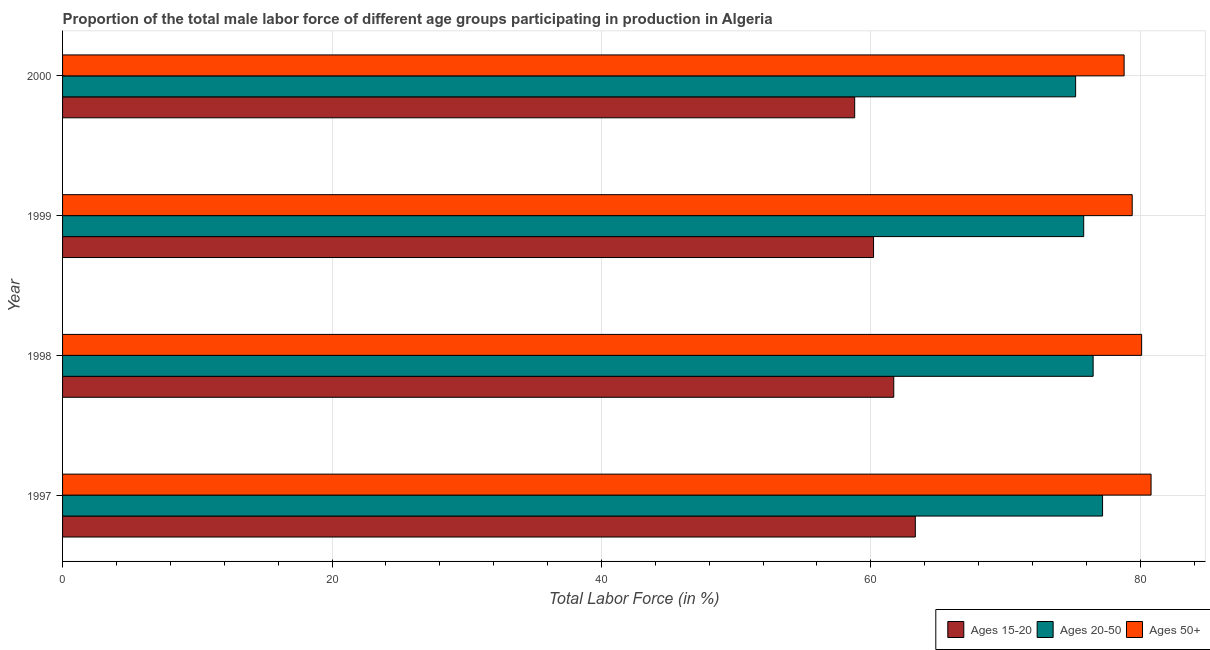How many different coloured bars are there?
Keep it short and to the point. 3. How many groups of bars are there?
Your answer should be compact. 4. Are the number of bars on each tick of the Y-axis equal?
Offer a terse response. Yes. How many bars are there on the 1st tick from the top?
Offer a very short reply. 3. What is the percentage of male labor force above age 50 in 1999?
Provide a succinct answer. 79.4. Across all years, what is the maximum percentage of male labor force within the age group 20-50?
Your answer should be compact. 77.2. Across all years, what is the minimum percentage of male labor force above age 50?
Your answer should be compact. 78.8. In which year was the percentage of male labor force above age 50 maximum?
Ensure brevity in your answer.  1997. What is the total percentage of male labor force above age 50 in the graph?
Make the answer very short. 319.1. What is the difference between the percentage of male labor force above age 50 in 1997 and the percentage of male labor force within the age group 15-20 in 1998?
Your response must be concise. 19.1. What is the average percentage of male labor force above age 50 per year?
Your answer should be compact. 79.78. In the year 2000, what is the difference between the percentage of male labor force within the age group 20-50 and percentage of male labor force within the age group 15-20?
Ensure brevity in your answer.  16.4. What is the ratio of the percentage of male labor force within the age group 15-20 in 1997 to that in 1999?
Offer a terse response. 1.05. What does the 2nd bar from the top in 1999 represents?
Your answer should be compact. Ages 20-50. What does the 2nd bar from the bottom in 1997 represents?
Offer a very short reply. Ages 20-50. Is it the case that in every year, the sum of the percentage of male labor force within the age group 15-20 and percentage of male labor force within the age group 20-50 is greater than the percentage of male labor force above age 50?
Ensure brevity in your answer.  Yes. What is the difference between two consecutive major ticks on the X-axis?
Offer a terse response. 20. Does the graph contain any zero values?
Offer a terse response. No. Does the graph contain grids?
Ensure brevity in your answer.  Yes. Where does the legend appear in the graph?
Make the answer very short. Bottom right. How many legend labels are there?
Your response must be concise. 3. How are the legend labels stacked?
Your answer should be very brief. Horizontal. What is the title of the graph?
Make the answer very short. Proportion of the total male labor force of different age groups participating in production in Algeria. What is the label or title of the Y-axis?
Your answer should be compact. Year. What is the Total Labor Force (in %) in Ages 15-20 in 1997?
Give a very brief answer. 63.3. What is the Total Labor Force (in %) in Ages 20-50 in 1997?
Your answer should be very brief. 77.2. What is the Total Labor Force (in %) of Ages 50+ in 1997?
Provide a succinct answer. 80.8. What is the Total Labor Force (in %) in Ages 15-20 in 1998?
Provide a short and direct response. 61.7. What is the Total Labor Force (in %) of Ages 20-50 in 1998?
Give a very brief answer. 76.5. What is the Total Labor Force (in %) in Ages 50+ in 1998?
Offer a very short reply. 80.1. What is the Total Labor Force (in %) in Ages 15-20 in 1999?
Keep it short and to the point. 60.2. What is the Total Labor Force (in %) in Ages 20-50 in 1999?
Your answer should be very brief. 75.8. What is the Total Labor Force (in %) of Ages 50+ in 1999?
Provide a short and direct response. 79.4. What is the Total Labor Force (in %) in Ages 15-20 in 2000?
Your answer should be very brief. 58.8. What is the Total Labor Force (in %) of Ages 20-50 in 2000?
Offer a terse response. 75.2. What is the Total Labor Force (in %) of Ages 50+ in 2000?
Your answer should be compact. 78.8. Across all years, what is the maximum Total Labor Force (in %) in Ages 15-20?
Offer a terse response. 63.3. Across all years, what is the maximum Total Labor Force (in %) of Ages 20-50?
Ensure brevity in your answer.  77.2. Across all years, what is the maximum Total Labor Force (in %) of Ages 50+?
Give a very brief answer. 80.8. Across all years, what is the minimum Total Labor Force (in %) of Ages 15-20?
Ensure brevity in your answer.  58.8. Across all years, what is the minimum Total Labor Force (in %) in Ages 20-50?
Your response must be concise. 75.2. Across all years, what is the minimum Total Labor Force (in %) in Ages 50+?
Your response must be concise. 78.8. What is the total Total Labor Force (in %) of Ages 15-20 in the graph?
Your response must be concise. 244. What is the total Total Labor Force (in %) of Ages 20-50 in the graph?
Make the answer very short. 304.7. What is the total Total Labor Force (in %) in Ages 50+ in the graph?
Your response must be concise. 319.1. What is the difference between the Total Labor Force (in %) in Ages 15-20 in 1997 and that in 1998?
Make the answer very short. 1.6. What is the difference between the Total Labor Force (in %) in Ages 50+ in 1997 and that in 1998?
Give a very brief answer. 0.7. What is the difference between the Total Labor Force (in %) of Ages 15-20 in 1997 and that in 1999?
Your answer should be compact. 3.1. What is the difference between the Total Labor Force (in %) in Ages 15-20 in 1997 and that in 2000?
Give a very brief answer. 4.5. What is the difference between the Total Labor Force (in %) in Ages 20-50 in 1998 and that in 1999?
Keep it short and to the point. 0.7. What is the difference between the Total Labor Force (in %) in Ages 50+ in 1998 and that in 1999?
Your answer should be very brief. 0.7. What is the difference between the Total Labor Force (in %) of Ages 20-50 in 1998 and that in 2000?
Offer a terse response. 1.3. What is the difference between the Total Labor Force (in %) of Ages 50+ in 1998 and that in 2000?
Ensure brevity in your answer.  1.3. What is the difference between the Total Labor Force (in %) in Ages 20-50 in 1999 and that in 2000?
Keep it short and to the point. 0.6. What is the difference between the Total Labor Force (in %) of Ages 15-20 in 1997 and the Total Labor Force (in %) of Ages 20-50 in 1998?
Provide a short and direct response. -13.2. What is the difference between the Total Labor Force (in %) in Ages 15-20 in 1997 and the Total Labor Force (in %) in Ages 50+ in 1998?
Provide a short and direct response. -16.8. What is the difference between the Total Labor Force (in %) of Ages 20-50 in 1997 and the Total Labor Force (in %) of Ages 50+ in 1998?
Give a very brief answer. -2.9. What is the difference between the Total Labor Force (in %) in Ages 15-20 in 1997 and the Total Labor Force (in %) in Ages 20-50 in 1999?
Make the answer very short. -12.5. What is the difference between the Total Labor Force (in %) of Ages 15-20 in 1997 and the Total Labor Force (in %) of Ages 50+ in 1999?
Offer a terse response. -16.1. What is the difference between the Total Labor Force (in %) of Ages 20-50 in 1997 and the Total Labor Force (in %) of Ages 50+ in 1999?
Provide a short and direct response. -2.2. What is the difference between the Total Labor Force (in %) in Ages 15-20 in 1997 and the Total Labor Force (in %) in Ages 50+ in 2000?
Ensure brevity in your answer.  -15.5. What is the difference between the Total Labor Force (in %) of Ages 15-20 in 1998 and the Total Labor Force (in %) of Ages 20-50 in 1999?
Your response must be concise. -14.1. What is the difference between the Total Labor Force (in %) in Ages 15-20 in 1998 and the Total Labor Force (in %) in Ages 50+ in 1999?
Your answer should be very brief. -17.7. What is the difference between the Total Labor Force (in %) of Ages 20-50 in 1998 and the Total Labor Force (in %) of Ages 50+ in 1999?
Offer a very short reply. -2.9. What is the difference between the Total Labor Force (in %) of Ages 15-20 in 1998 and the Total Labor Force (in %) of Ages 20-50 in 2000?
Your response must be concise. -13.5. What is the difference between the Total Labor Force (in %) in Ages 15-20 in 1998 and the Total Labor Force (in %) in Ages 50+ in 2000?
Offer a very short reply. -17.1. What is the difference between the Total Labor Force (in %) in Ages 15-20 in 1999 and the Total Labor Force (in %) in Ages 50+ in 2000?
Offer a very short reply. -18.6. What is the difference between the Total Labor Force (in %) in Ages 20-50 in 1999 and the Total Labor Force (in %) in Ages 50+ in 2000?
Your response must be concise. -3. What is the average Total Labor Force (in %) in Ages 20-50 per year?
Give a very brief answer. 76.17. What is the average Total Labor Force (in %) in Ages 50+ per year?
Offer a very short reply. 79.78. In the year 1997, what is the difference between the Total Labor Force (in %) in Ages 15-20 and Total Labor Force (in %) in Ages 50+?
Provide a short and direct response. -17.5. In the year 1997, what is the difference between the Total Labor Force (in %) in Ages 20-50 and Total Labor Force (in %) in Ages 50+?
Your answer should be very brief. -3.6. In the year 1998, what is the difference between the Total Labor Force (in %) of Ages 15-20 and Total Labor Force (in %) of Ages 20-50?
Your response must be concise. -14.8. In the year 1998, what is the difference between the Total Labor Force (in %) of Ages 15-20 and Total Labor Force (in %) of Ages 50+?
Your answer should be compact. -18.4. In the year 1999, what is the difference between the Total Labor Force (in %) in Ages 15-20 and Total Labor Force (in %) in Ages 20-50?
Your answer should be very brief. -15.6. In the year 1999, what is the difference between the Total Labor Force (in %) of Ages 15-20 and Total Labor Force (in %) of Ages 50+?
Give a very brief answer. -19.2. In the year 2000, what is the difference between the Total Labor Force (in %) of Ages 15-20 and Total Labor Force (in %) of Ages 20-50?
Your answer should be very brief. -16.4. In the year 2000, what is the difference between the Total Labor Force (in %) in Ages 15-20 and Total Labor Force (in %) in Ages 50+?
Provide a short and direct response. -20. What is the ratio of the Total Labor Force (in %) of Ages 15-20 in 1997 to that in 1998?
Your response must be concise. 1.03. What is the ratio of the Total Labor Force (in %) in Ages 20-50 in 1997 to that in 1998?
Offer a terse response. 1.01. What is the ratio of the Total Labor Force (in %) of Ages 50+ in 1997 to that in 1998?
Provide a short and direct response. 1.01. What is the ratio of the Total Labor Force (in %) of Ages 15-20 in 1997 to that in 1999?
Provide a short and direct response. 1.05. What is the ratio of the Total Labor Force (in %) of Ages 20-50 in 1997 to that in 1999?
Offer a terse response. 1.02. What is the ratio of the Total Labor Force (in %) in Ages 50+ in 1997 to that in 1999?
Ensure brevity in your answer.  1.02. What is the ratio of the Total Labor Force (in %) in Ages 15-20 in 1997 to that in 2000?
Offer a very short reply. 1.08. What is the ratio of the Total Labor Force (in %) of Ages 20-50 in 1997 to that in 2000?
Offer a terse response. 1.03. What is the ratio of the Total Labor Force (in %) in Ages 50+ in 1997 to that in 2000?
Offer a very short reply. 1.03. What is the ratio of the Total Labor Force (in %) in Ages 15-20 in 1998 to that in 1999?
Offer a terse response. 1.02. What is the ratio of the Total Labor Force (in %) in Ages 20-50 in 1998 to that in 1999?
Provide a short and direct response. 1.01. What is the ratio of the Total Labor Force (in %) of Ages 50+ in 1998 to that in 1999?
Keep it short and to the point. 1.01. What is the ratio of the Total Labor Force (in %) of Ages 15-20 in 1998 to that in 2000?
Your answer should be compact. 1.05. What is the ratio of the Total Labor Force (in %) in Ages 20-50 in 1998 to that in 2000?
Offer a terse response. 1.02. What is the ratio of the Total Labor Force (in %) in Ages 50+ in 1998 to that in 2000?
Provide a short and direct response. 1.02. What is the ratio of the Total Labor Force (in %) of Ages 15-20 in 1999 to that in 2000?
Your response must be concise. 1.02. What is the ratio of the Total Labor Force (in %) in Ages 20-50 in 1999 to that in 2000?
Provide a succinct answer. 1.01. What is the ratio of the Total Labor Force (in %) in Ages 50+ in 1999 to that in 2000?
Keep it short and to the point. 1.01. What is the difference between the highest and the second highest Total Labor Force (in %) in Ages 15-20?
Provide a succinct answer. 1.6. What is the difference between the highest and the second highest Total Labor Force (in %) of Ages 20-50?
Ensure brevity in your answer.  0.7. What is the difference between the highest and the second highest Total Labor Force (in %) of Ages 50+?
Your response must be concise. 0.7. What is the difference between the highest and the lowest Total Labor Force (in %) in Ages 15-20?
Give a very brief answer. 4.5. What is the difference between the highest and the lowest Total Labor Force (in %) of Ages 20-50?
Your answer should be very brief. 2. 